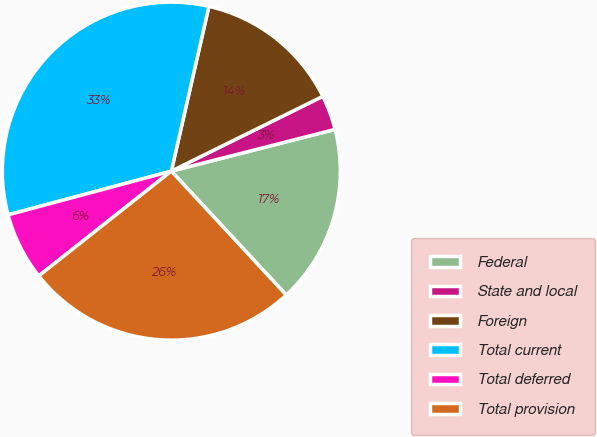Convert chart to OTSL. <chart><loc_0><loc_0><loc_500><loc_500><pie_chart><fcel>Federal<fcel>State and local<fcel>Foreign<fcel>Total current<fcel>Total deferred<fcel>Total provision<nl><fcel>17.07%<fcel>3.33%<fcel>14.13%<fcel>32.74%<fcel>6.48%<fcel>26.26%<nl></chart> 